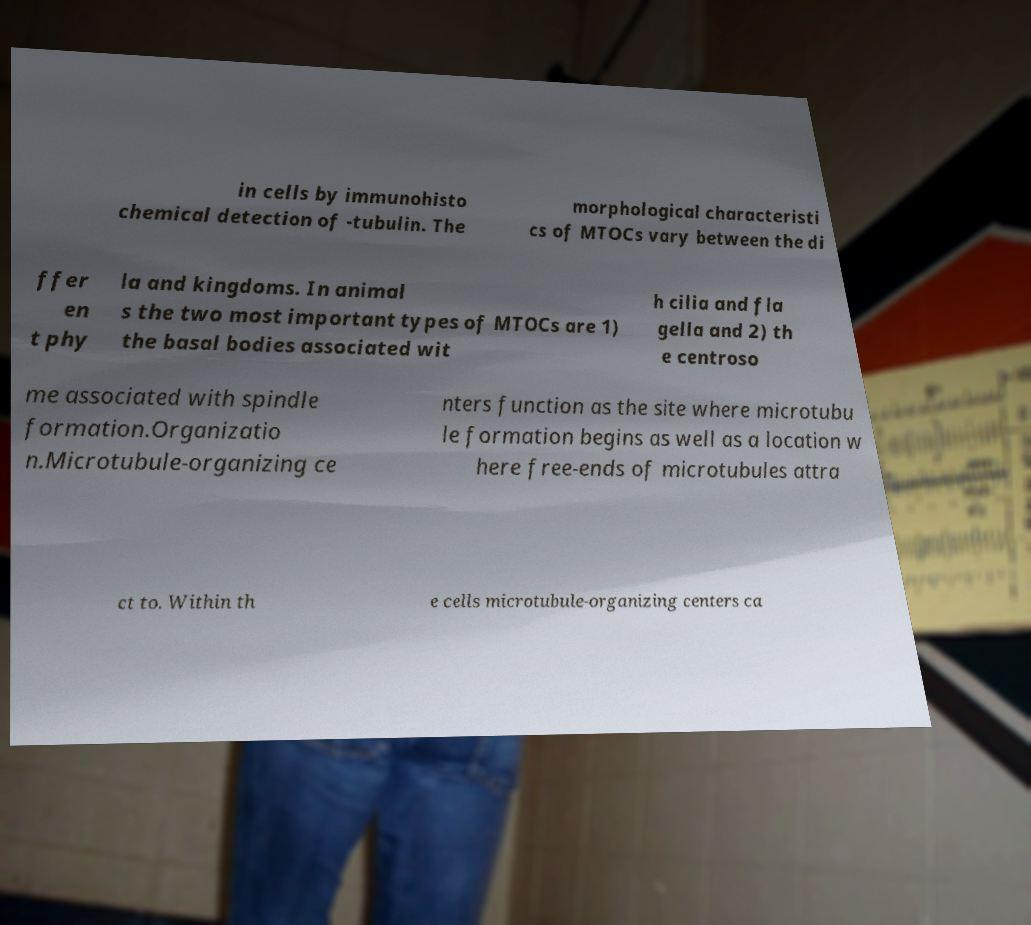Can you accurately transcribe the text from the provided image for me? in cells by immunohisto chemical detection of -tubulin. The morphological characteristi cs of MTOCs vary between the di ffer en t phy la and kingdoms. In animal s the two most important types of MTOCs are 1) the basal bodies associated wit h cilia and fla gella and 2) th e centroso me associated with spindle formation.Organizatio n.Microtubule-organizing ce nters function as the site where microtubu le formation begins as well as a location w here free-ends of microtubules attra ct to. Within th e cells microtubule-organizing centers ca 